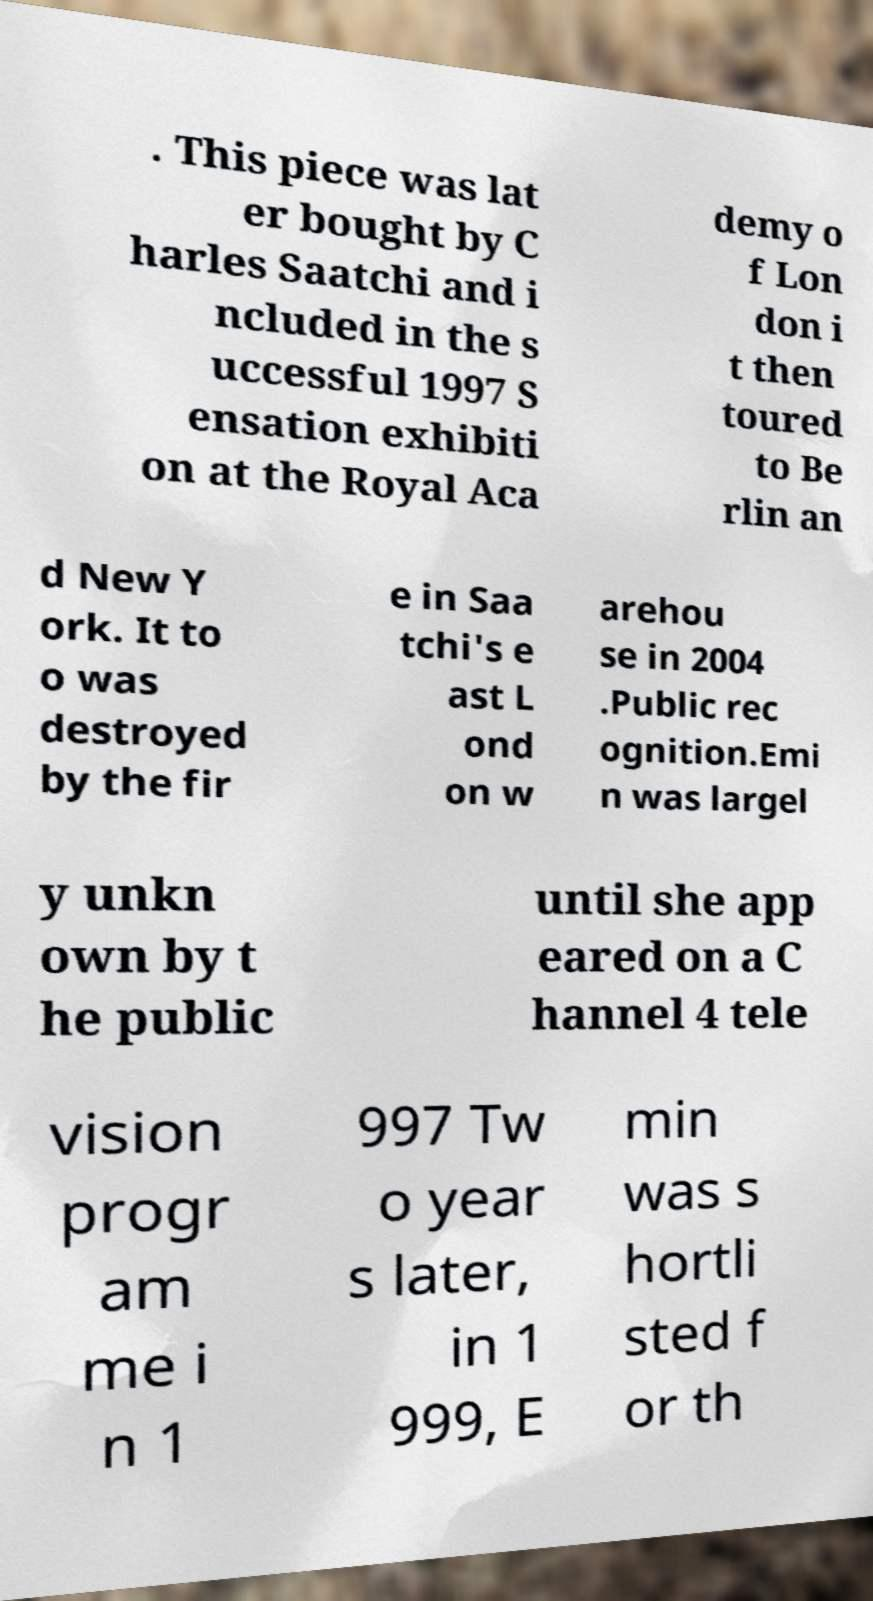What messages or text are displayed in this image? I need them in a readable, typed format. . This piece was lat er bought by C harles Saatchi and i ncluded in the s uccessful 1997 S ensation exhibiti on at the Royal Aca demy o f Lon don i t then toured to Be rlin an d New Y ork. It to o was destroyed by the fir e in Saa tchi's e ast L ond on w arehou se in 2004 .Public rec ognition.Emi n was largel y unkn own by t he public until she app eared on a C hannel 4 tele vision progr am me i n 1 997 Tw o year s later, in 1 999, E min was s hortli sted f or th 